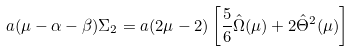Convert formula to latex. <formula><loc_0><loc_0><loc_500><loc_500>a ( \mu - \alpha - \beta ) \Sigma _ { 2 } = a ( 2 \mu - 2 ) \left [ \frac { 5 } { 6 } \hat { \Omega } ( \mu ) + 2 \hat { \Theta } ^ { 2 } ( \mu ) \right ]</formula> 